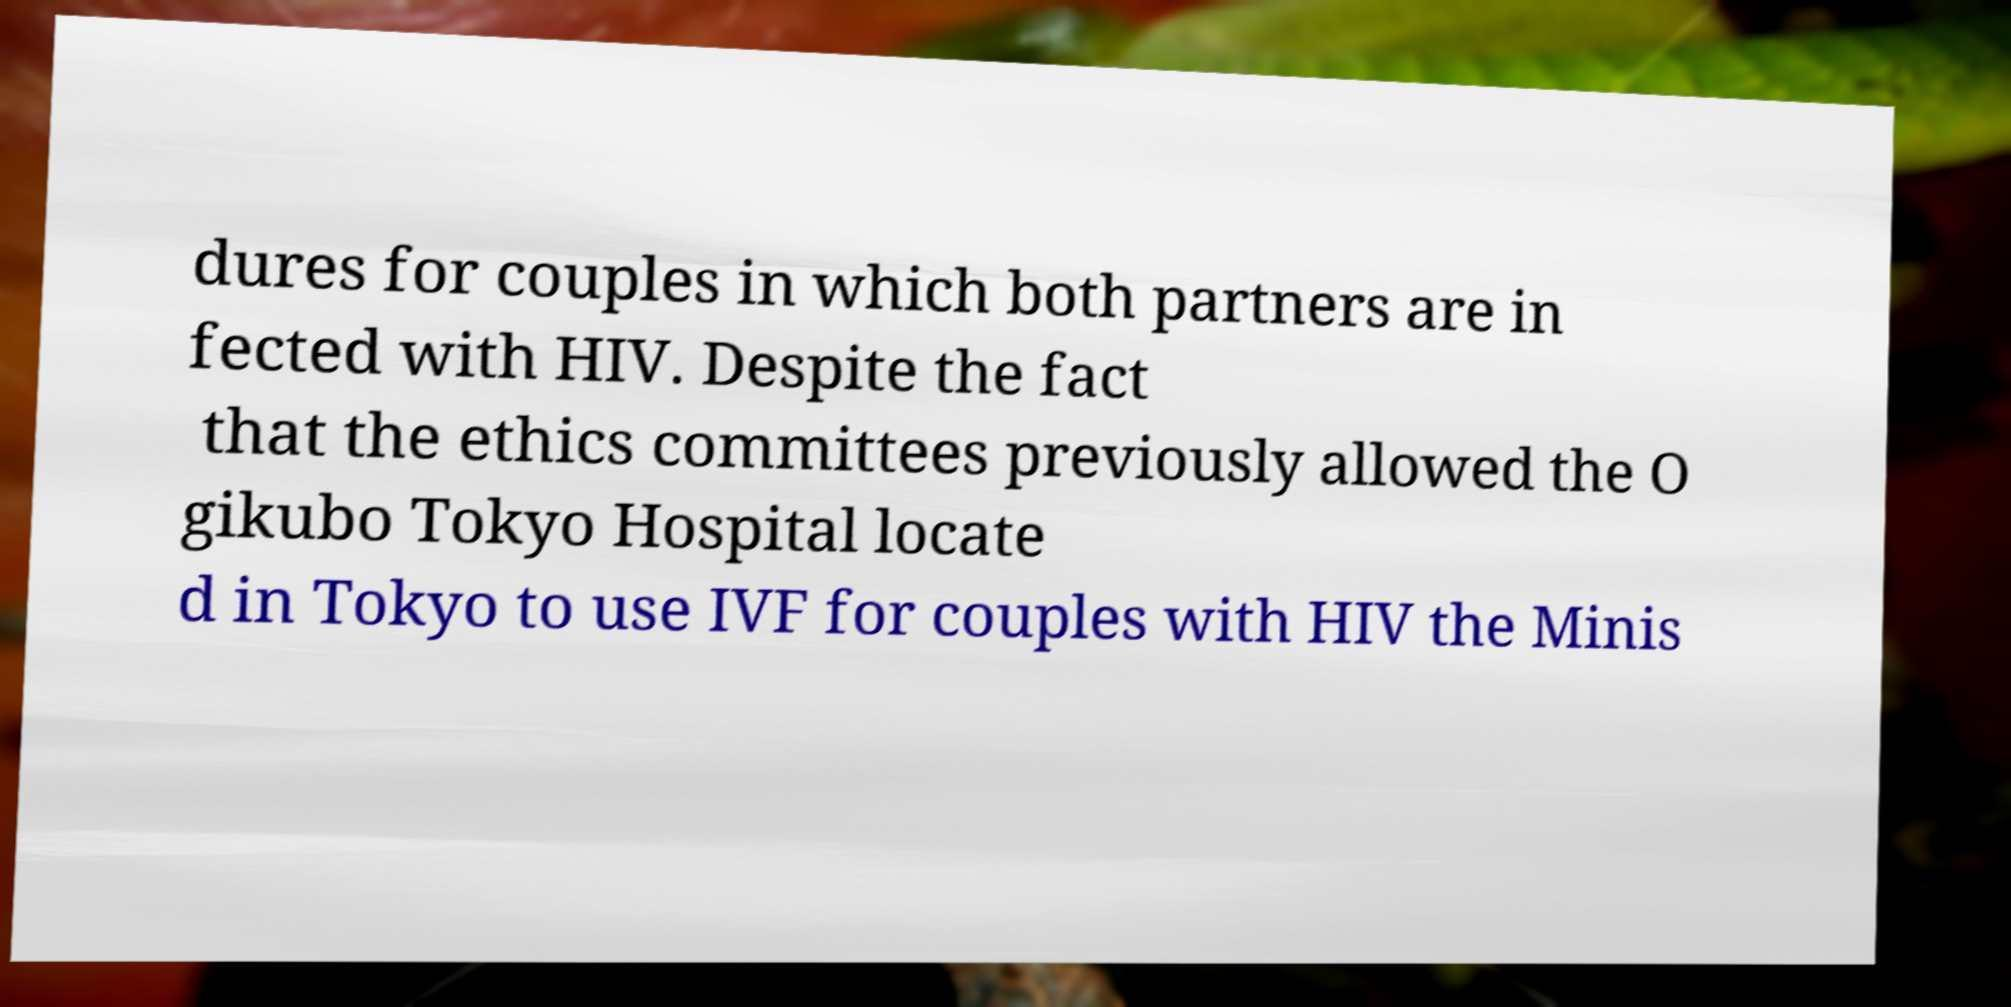Please read and relay the text visible in this image. What does it say? dures for couples in which both partners are in fected with HIV. Despite the fact that the ethics committees previously allowed the O gikubo Tokyo Hospital locate d in Tokyo to use IVF for couples with HIV the Minis 